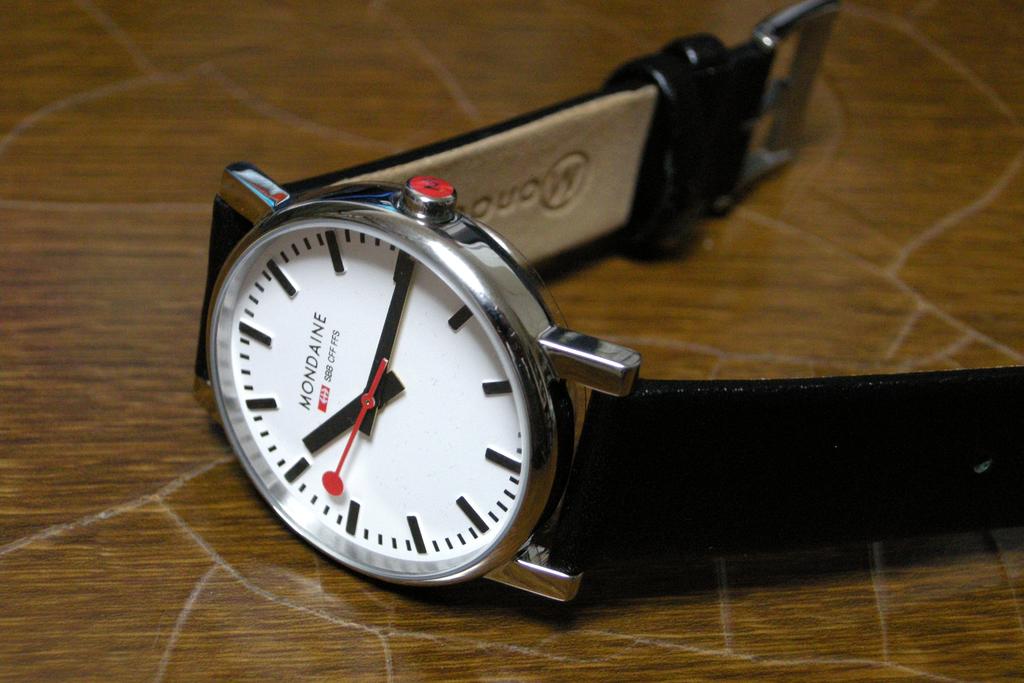What is the brand of the watch?
Give a very brief answer. Mondaine. What time is displayed?
Your answer should be compact. 10:15. 